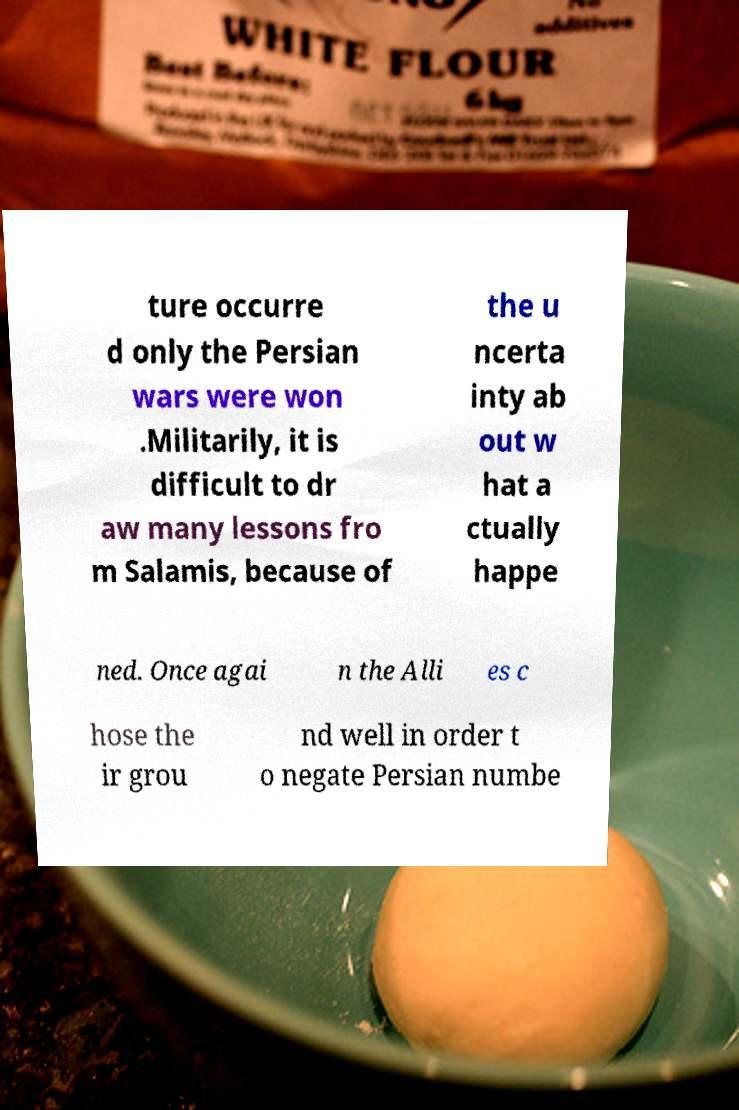Can you read and provide the text displayed in the image?This photo seems to have some interesting text. Can you extract and type it out for me? ture occurre d only the Persian wars were won .Militarily, it is difficult to dr aw many lessons fro m Salamis, because of the u ncerta inty ab out w hat a ctually happe ned. Once agai n the Alli es c hose the ir grou nd well in order t o negate Persian numbe 